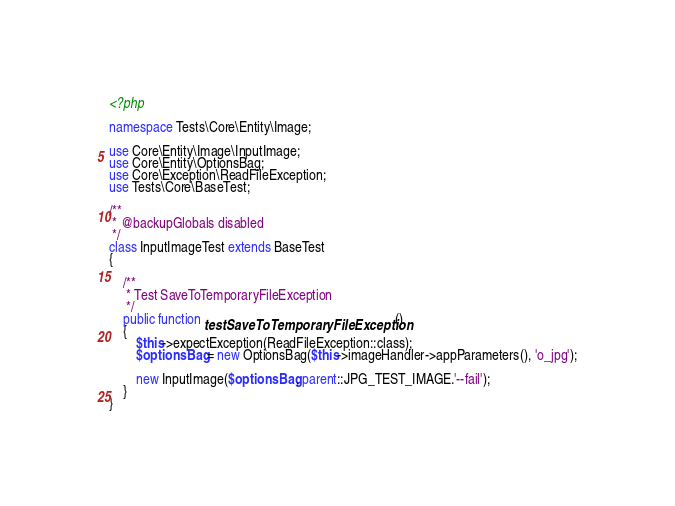Convert code to text. <code><loc_0><loc_0><loc_500><loc_500><_PHP_><?php

namespace Tests\Core\Entity\Image;

use Core\Entity\Image\InputImage;
use Core\Entity\OptionsBag;
use Core\Exception\ReadFileException;
use Tests\Core\BaseTest;

/**
 * @backupGlobals disabled
 */
class InputImageTest extends BaseTest
{

    /**
     * Test SaveToTemporaryFileException
     */
    public function testSaveToTemporaryFileException()
    {
        $this->expectException(ReadFileException::class);
        $optionsBag = new OptionsBag($this->imageHandler->appParameters(), 'o_jpg');

        new InputImage($optionsBag, parent::JPG_TEST_IMAGE.'--fail');
    }
}
</code> 